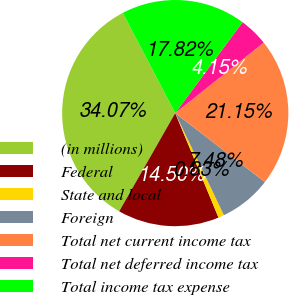<chart> <loc_0><loc_0><loc_500><loc_500><pie_chart><fcel>(in millions)<fcel>Federal<fcel>State and local<fcel>Foreign<fcel>Total net current income tax<fcel>Total net deferred income tax<fcel>Total income tax expense<nl><fcel>34.07%<fcel>14.5%<fcel>0.83%<fcel>7.48%<fcel>21.15%<fcel>4.15%<fcel>17.82%<nl></chart> 